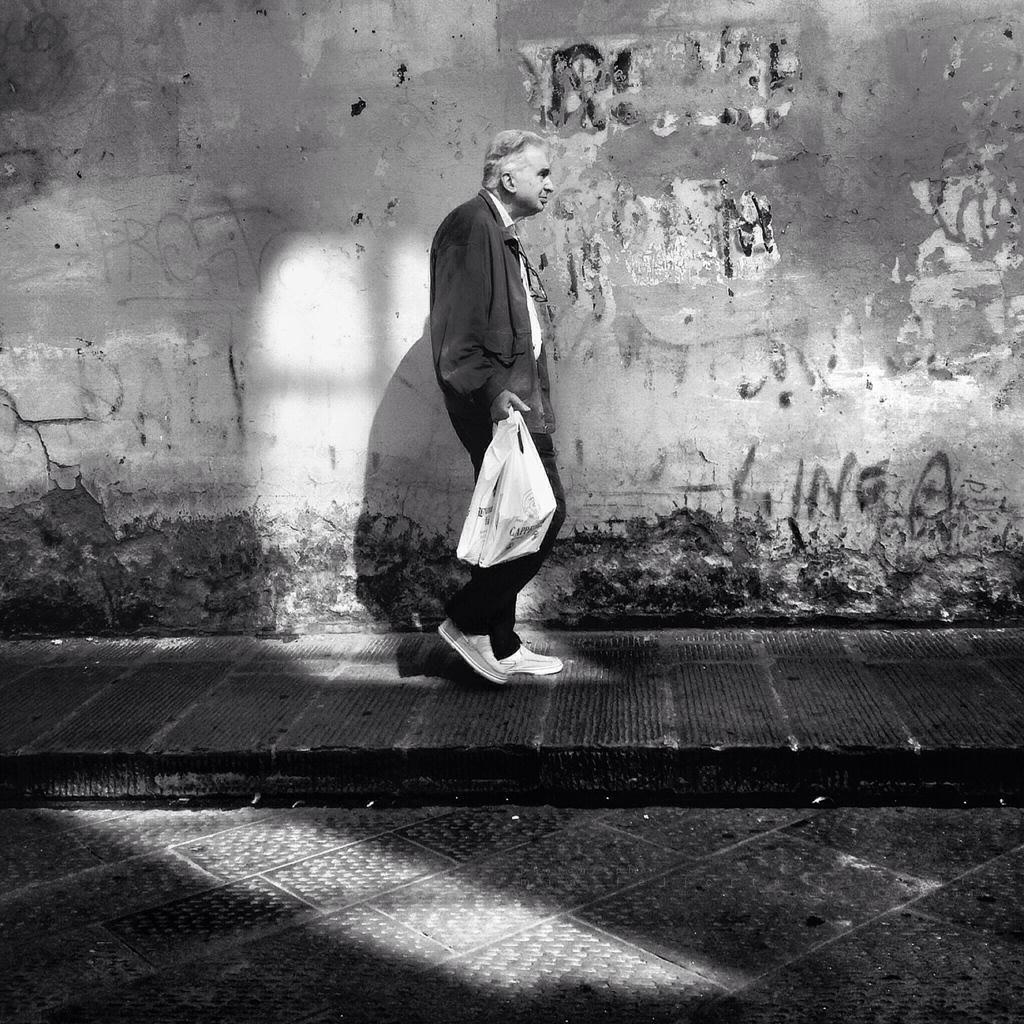What is the color scheme of the image? The image is black and white. What is the man in the image doing? The man is walking in the image. What is the man holding while walking? The man is holding a cover. Where is the man walking? The man is walking on a footpath. What can be seen in the background of the image? There is a wall in the background of the image. What is on the wall in the background? There is a painting on the wall. What type of zebra can be seen performing an action in the image? There is no zebra present in the image, and therefore no such action can be observed. Is the man in the image a doctor? The image does not provide any information about the man's profession, so it cannot be determined if he is a doctor. 